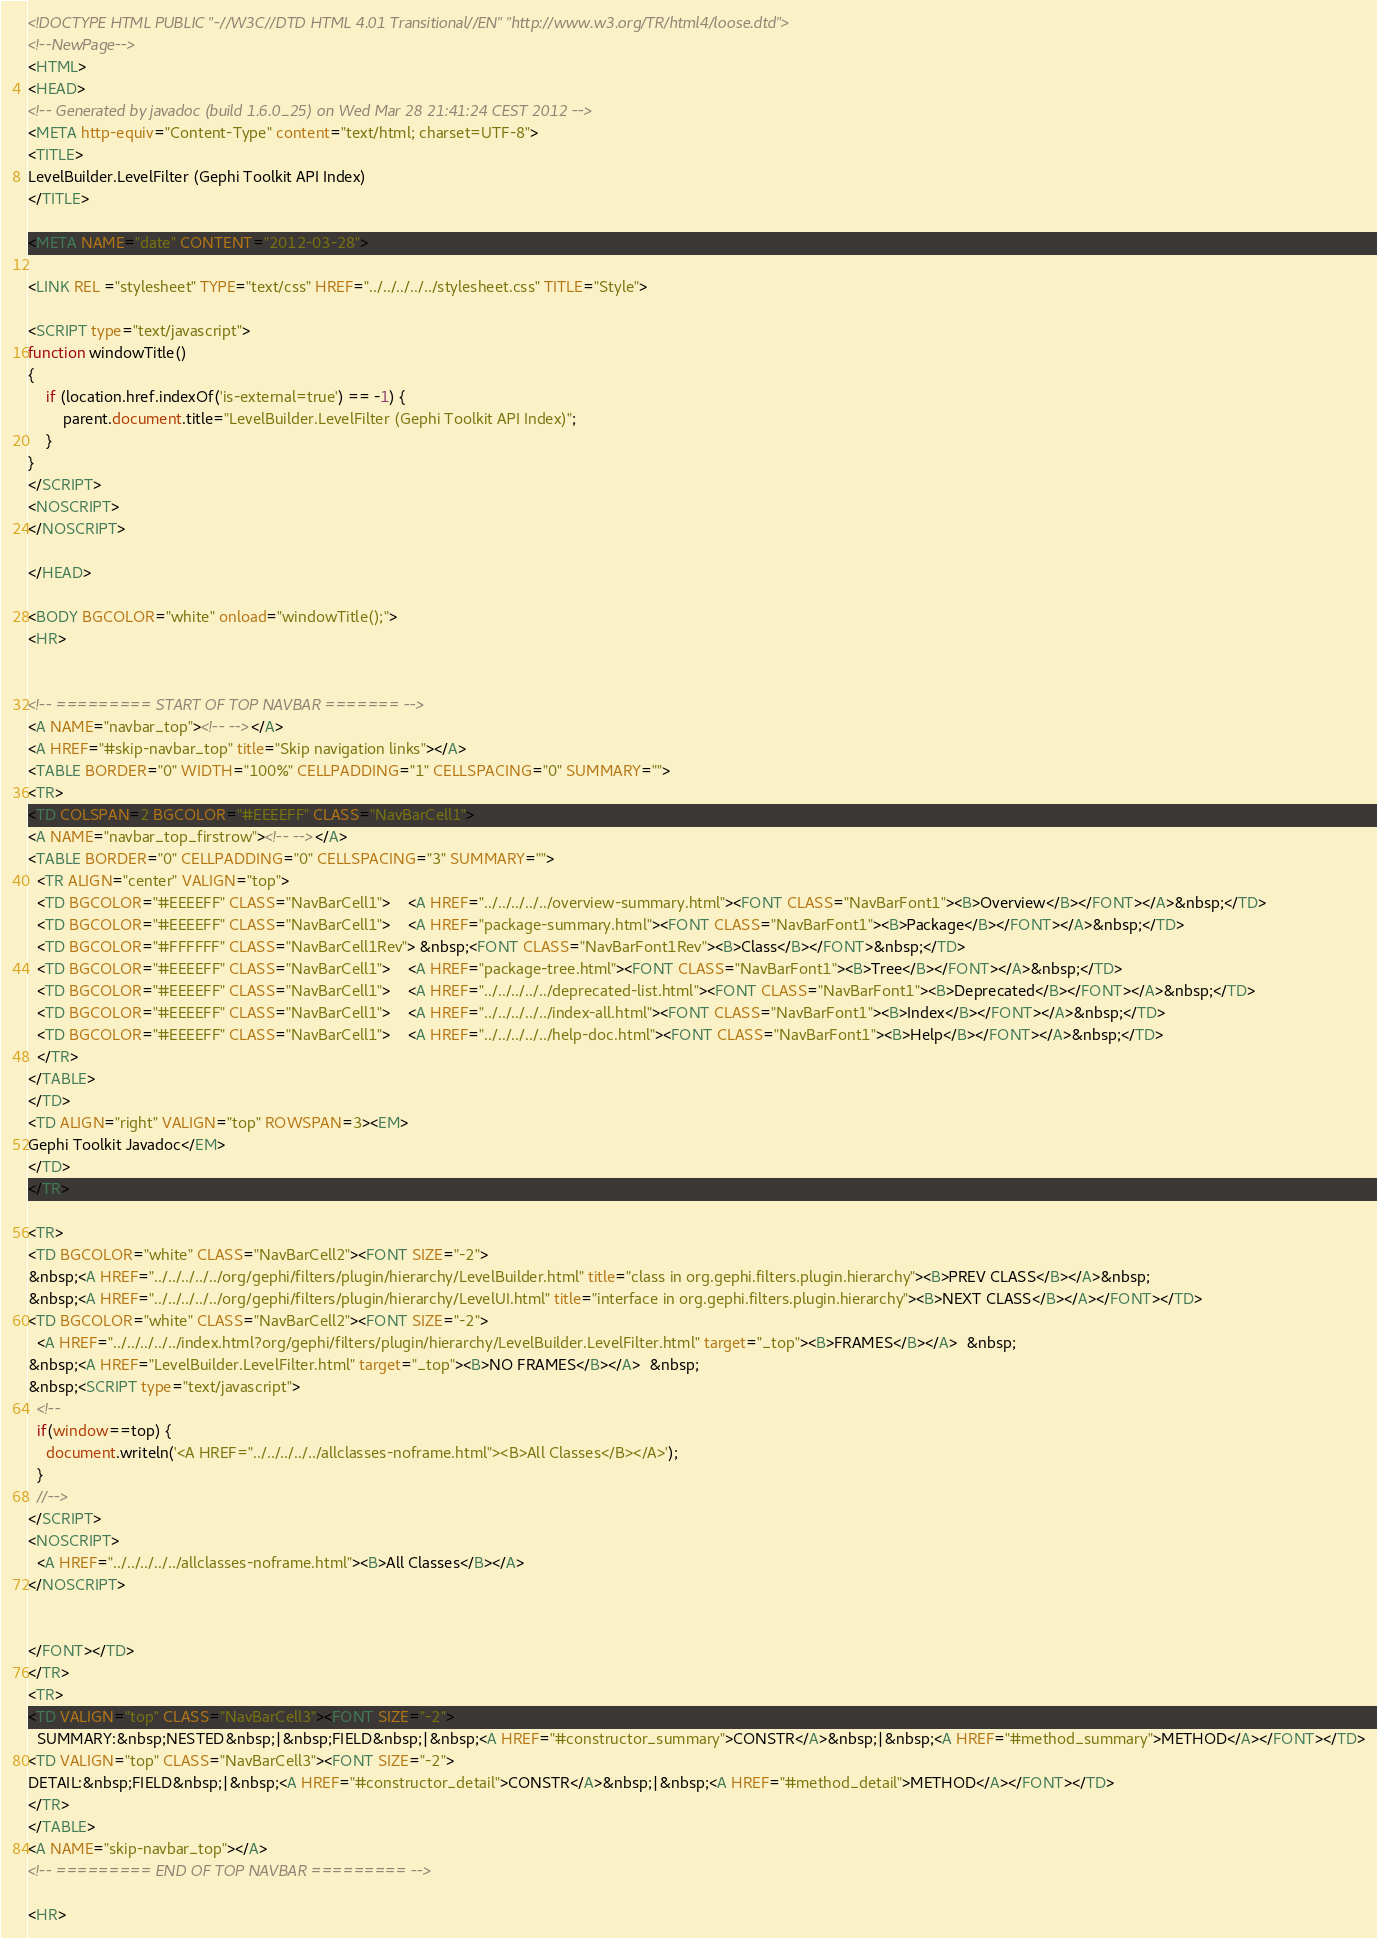<code> <loc_0><loc_0><loc_500><loc_500><_HTML_><!DOCTYPE HTML PUBLIC "-//W3C//DTD HTML 4.01 Transitional//EN" "http://www.w3.org/TR/html4/loose.dtd">
<!--NewPage-->
<HTML>
<HEAD>
<!-- Generated by javadoc (build 1.6.0_25) on Wed Mar 28 21:41:24 CEST 2012 -->
<META http-equiv="Content-Type" content="text/html; charset=UTF-8">
<TITLE>
LevelBuilder.LevelFilter (Gephi Toolkit API Index)
</TITLE>

<META NAME="date" CONTENT="2012-03-28">

<LINK REL ="stylesheet" TYPE="text/css" HREF="../../../../../stylesheet.css" TITLE="Style">

<SCRIPT type="text/javascript">
function windowTitle()
{
    if (location.href.indexOf('is-external=true') == -1) {
        parent.document.title="LevelBuilder.LevelFilter (Gephi Toolkit API Index)";
    }
}
</SCRIPT>
<NOSCRIPT>
</NOSCRIPT>

</HEAD>

<BODY BGCOLOR="white" onload="windowTitle();">
<HR>


<!-- ========= START OF TOP NAVBAR ======= -->
<A NAME="navbar_top"><!-- --></A>
<A HREF="#skip-navbar_top" title="Skip navigation links"></A>
<TABLE BORDER="0" WIDTH="100%" CELLPADDING="1" CELLSPACING="0" SUMMARY="">
<TR>
<TD COLSPAN=2 BGCOLOR="#EEEEFF" CLASS="NavBarCell1">
<A NAME="navbar_top_firstrow"><!-- --></A>
<TABLE BORDER="0" CELLPADDING="0" CELLSPACING="3" SUMMARY="">
  <TR ALIGN="center" VALIGN="top">
  <TD BGCOLOR="#EEEEFF" CLASS="NavBarCell1">    <A HREF="../../../../../overview-summary.html"><FONT CLASS="NavBarFont1"><B>Overview</B></FONT></A>&nbsp;</TD>
  <TD BGCOLOR="#EEEEFF" CLASS="NavBarCell1">    <A HREF="package-summary.html"><FONT CLASS="NavBarFont1"><B>Package</B></FONT></A>&nbsp;</TD>
  <TD BGCOLOR="#FFFFFF" CLASS="NavBarCell1Rev"> &nbsp;<FONT CLASS="NavBarFont1Rev"><B>Class</B></FONT>&nbsp;</TD>
  <TD BGCOLOR="#EEEEFF" CLASS="NavBarCell1">    <A HREF="package-tree.html"><FONT CLASS="NavBarFont1"><B>Tree</B></FONT></A>&nbsp;</TD>
  <TD BGCOLOR="#EEEEFF" CLASS="NavBarCell1">    <A HREF="../../../../../deprecated-list.html"><FONT CLASS="NavBarFont1"><B>Deprecated</B></FONT></A>&nbsp;</TD>
  <TD BGCOLOR="#EEEEFF" CLASS="NavBarCell1">    <A HREF="../../../../../index-all.html"><FONT CLASS="NavBarFont1"><B>Index</B></FONT></A>&nbsp;</TD>
  <TD BGCOLOR="#EEEEFF" CLASS="NavBarCell1">    <A HREF="../../../../../help-doc.html"><FONT CLASS="NavBarFont1"><B>Help</B></FONT></A>&nbsp;</TD>
  </TR>
</TABLE>
</TD>
<TD ALIGN="right" VALIGN="top" ROWSPAN=3><EM>
Gephi Toolkit Javadoc</EM>
</TD>
</TR>

<TR>
<TD BGCOLOR="white" CLASS="NavBarCell2"><FONT SIZE="-2">
&nbsp;<A HREF="../../../../../org/gephi/filters/plugin/hierarchy/LevelBuilder.html" title="class in org.gephi.filters.plugin.hierarchy"><B>PREV CLASS</B></A>&nbsp;
&nbsp;<A HREF="../../../../../org/gephi/filters/plugin/hierarchy/LevelUI.html" title="interface in org.gephi.filters.plugin.hierarchy"><B>NEXT CLASS</B></A></FONT></TD>
<TD BGCOLOR="white" CLASS="NavBarCell2"><FONT SIZE="-2">
  <A HREF="../../../../../index.html?org/gephi/filters/plugin/hierarchy/LevelBuilder.LevelFilter.html" target="_top"><B>FRAMES</B></A>  &nbsp;
&nbsp;<A HREF="LevelBuilder.LevelFilter.html" target="_top"><B>NO FRAMES</B></A>  &nbsp;
&nbsp;<SCRIPT type="text/javascript">
  <!--
  if(window==top) {
    document.writeln('<A HREF="../../../../../allclasses-noframe.html"><B>All Classes</B></A>');
  }
  //-->
</SCRIPT>
<NOSCRIPT>
  <A HREF="../../../../../allclasses-noframe.html"><B>All Classes</B></A>
</NOSCRIPT>


</FONT></TD>
</TR>
<TR>
<TD VALIGN="top" CLASS="NavBarCell3"><FONT SIZE="-2">
  SUMMARY:&nbsp;NESTED&nbsp;|&nbsp;FIELD&nbsp;|&nbsp;<A HREF="#constructor_summary">CONSTR</A>&nbsp;|&nbsp;<A HREF="#method_summary">METHOD</A></FONT></TD>
<TD VALIGN="top" CLASS="NavBarCell3"><FONT SIZE="-2">
DETAIL:&nbsp;FIELD&nbsp;|&nbsp;<A HREF="#constructor_detail">CONSTR</A>&nbsp;|&nbsp;<A HREF="#method_detail">METHOD</A></FONT></TD>
</TR>
</TABLE>
<A NAME="skip-navbar_top"></A>
<!-- ========= END OF TOP NAVBAR ========= -->

<HR></code> 